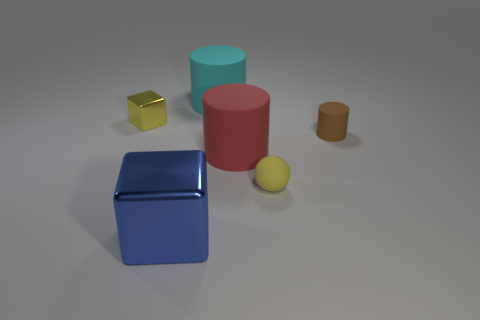Is there any other thing that is the same shape as the small yellow rubber object?
Offer a very short reply. No. Is there anything else that has the same material as the blue thing?
Offer a very short reply. Yes. What is the material of the large blue thing that is the same shape as the small metal thing?
Offer a very short reply. Metal. Are there an equal number of small metal things behind the small yellow shiny block and large brown cylinders?
Your answer should be compact. Yes. How big is the object that is right of the red object and in front of the small brown rubber thing?
Your response must be concise. Small. Is there anything else that is the same color as the big shiny cube?
Provide a succinct answer. No. There is a metallic cube in front of the yellow object that is in front of the yellow metallic thing; how big is it?
Provide a succinct answer. Large. There is a large object that is both in front of the small block and behind the large blue metal object; what is its color?
Your response must be concise. Red. How many other objects are the same size as the brown cylinder?
Provide a short and direct response. 2. There is a yellow block; is its size the same as the cylinder that is behind the yellow metallic thing?
Your answer should be compact. No. 